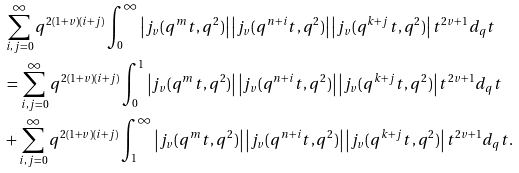Convert formula to latex. <formula><loc_0><loc_0><loc_500><loc_500>& \sum _ { i , j = 0 } ^ { \infty } q ^ { 2 ( 1 + v ) ( i + j ) } \int _ { 0 } ^ { \infty } \left | j _ { v } ( q ^ { m } t , q ^ { 2 } ) \right | \left | j _ { v } ( q ^ { n + i } t , q ^ { 2 } ) \right | \left | j _ { v } ( q ^ { k + j } t , q ^ { 2 } ) \right | t ^ { 2 v + 1 } d _ { q } t \\ & = \sum _ { i , j = 0 } ^ { \infty } q ^ { 2 ( 1 + v ) ( i + j ) } \int _ { 0 } ^ { 1 } \left | j _ { v } ( q ^ { m } t , q ^ { 2 } ) \right | \left | j _ { v } ( q ^ { n + i } t , q ^ { 2 } ) \right | \left | j _ { v } ( q ^ { k + j } t , q ^ { 2 } ) \right | t ^ { 2 v + 1 } d _ { q } t \\ & + \sum _ { i , j = 0 } ^ { \infty } q ^ { 2 ( 1 + v ) ( i + j ) } \int _ { 1 } ^ { \infty } \left | j _ { v } ( q ^ { m } t , q ^ { 2 } ) \right | \left | j _ { v } ( q ^ { n + i } t , q ^ { 2 } ) \right | \left | j _ { v } ( q ^ { k + j } t , q ^ { 2 } ) \right | t ^ { 2 v + 1 } d _ { q } t .</formula> 